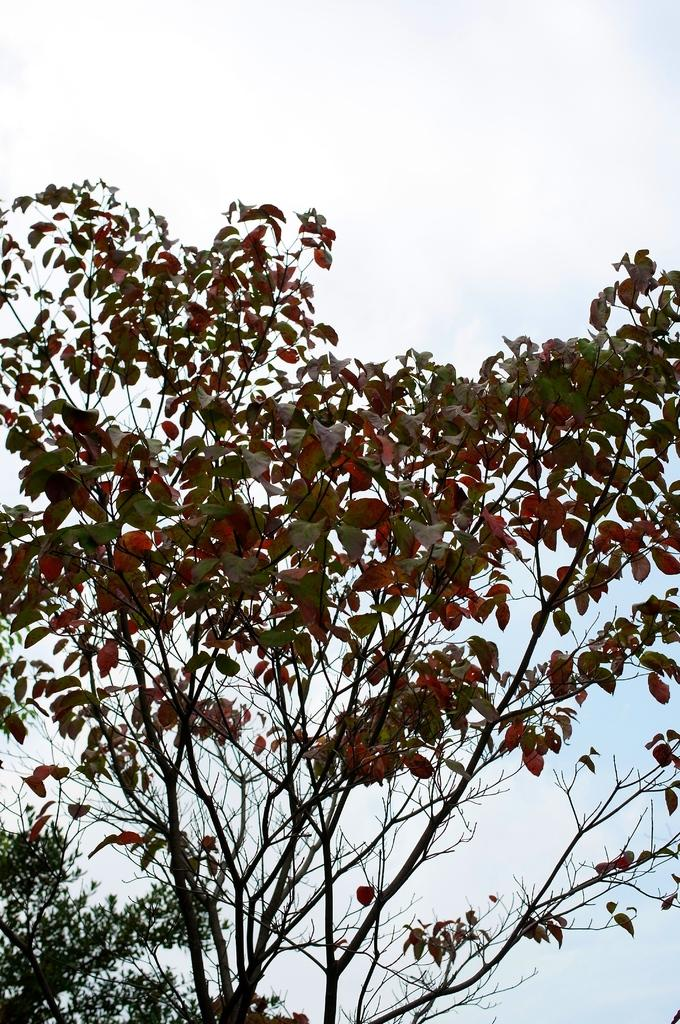What is present in the image? There is a plant in the image. What specific part of the plant can be seen? The plant has leaves. How many rabbits can be seen playing on the island in the image? There are no rabbits or islands present in the image; it features a plant with leaves. Is there a donkey visible in the image? A: There is no donkey present in the image; it features a plant with leaves. 